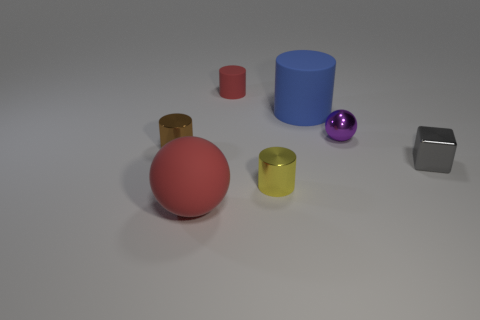There is a thing that is right of the blue thing and in front of the purple shiny ball; what size is it?
Your answer should be compact. Small. There is a rubber object that is right of the small red thing; does it have the same size as the red rubber object behind the large red thing?
Give a very brief answer. No. What number of other things are there of the same size as the brown metal object?
Provide a succinct answer. 4. There is a large object in front of the shiny object that is in front of the gray metallic cube; are there any small cylinders that are on the right side of it?
Your answer should be very brief. Yes. Are there any other things that have the same color as the big cylinder?
Provide a short and direct response. No. There is a red rubber thing behind the brown thing; what size is it?
Your response must be concise. Small. How big is the metal object on the right side of the sphere that is to the right of the matte thing that is to the left of the tiny red matte cylinder?
Your response must be concise. Small. The large matte thing on the right side of the red object that is behind the big cylinder is what color?
Keep it short and to the point. Blue. There is another tiny yellow object that is the same shape as the tiny matte object; what material is it?
Make the answer very short. Metal. Are there any big red objects in front of the purple sphere?
Provide a succinct answer. Yes. 